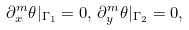Convert formula to latex. <formula><loc_0><loc_0><loc_500><loc_500>\partial _ { x } ^ { m } \theta | _ { \Gamma _ { 1 } } = 0 , \, \partial _ { y } ^ { m } \theta | _ { \Gamma _ { 2 } } = 0 ,</formula> 